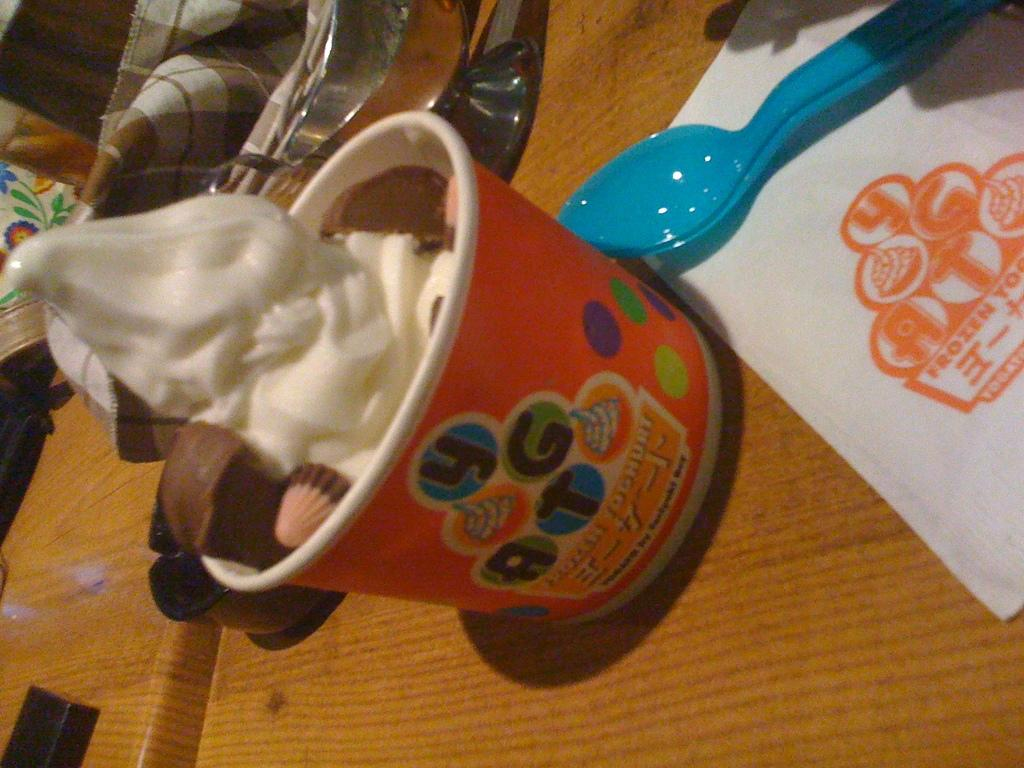What type of furniture is present in the image? There is a table in the image. What can be used for cleaning or wiping in the image? There are tissues in the image. What utensil is visible in the image? There is a spoon in the image. What is the bowl in the image used for? There is a bowl in the image that contains ice cream. What is covering the top of the image? There is a cloth at the top of the image. What type of organization is depicted in the image? There is no organization depicted in the image; it features a table, tissues, spoon, bowl, ice cream, and a cloth. How many dogs are present in the image? There are no dogs present in the image. 